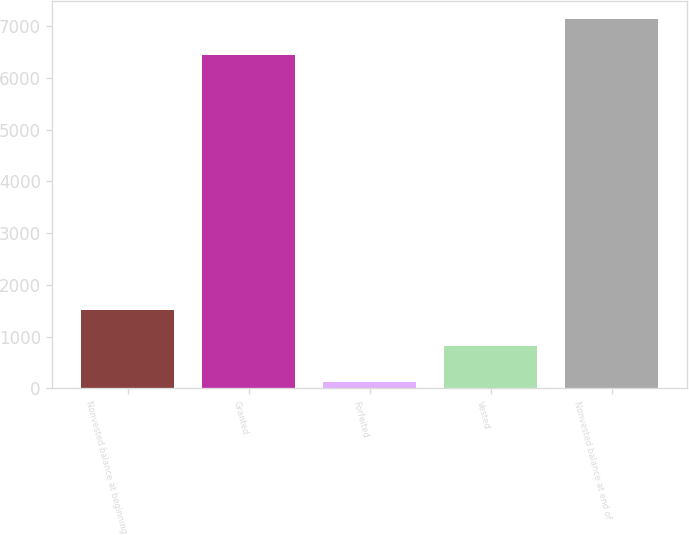<chart> <loc_0><loc_0><loc_500><loc_500><bar_chart><fcel>Nonvested balance at beginning<fcel>Granted<fcel>Forfeited<fcel>Vested<fcel>Nonvested balance at end of<nl><fcel>1511.6<fcel>6444<fcel>124<fcel>817.8<fcel>7137.8<nl></chart> 